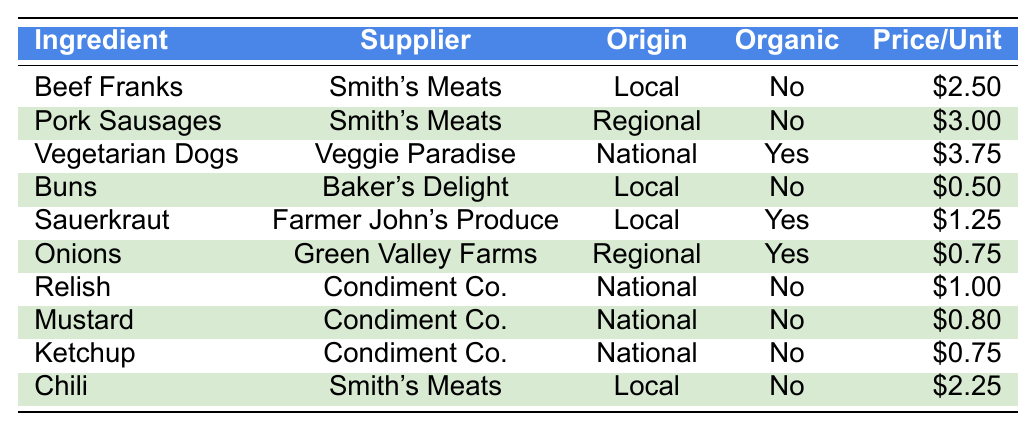What is the price per unit of vegetarian dogs? From the table, the entry for vegetarian dogs shows the price per unit is $3.75.
Answer: $3.75 Which supplier provides onions? According to the table, onions are supplied by Green Valley Farms.
Answer: Green Valley Farms How many ingredients are organic? In the table, there are 4 ingredients marked as organic: vegetarian dogs, sauerkraut, onions. The total count is therefore 3.
Answer: 3 Are all the buns supplied by Baker's Delight organic? The table indicates that the buns from Baker's Delight are not organic, making the statement false.
Answer: No What is the total price per unit for all ingredients supplied by Smith's Meats? Smith's Meats supplies beef franks ($2.50), pork sausages ($3.00), and chili ($2.25). The total price is $2.50 + $3.00 + $2.25 = $7.75.
Answer: $7.75 How much does the supplier of mustard charge compared to the supplier of sauerkraut? Mustard (Condiment Co.) costs $0.80, whereas sauerkraut (Farmer John's Produce) costs $1.25. Thus, sauerkraut is $1.25 - $0.80 = $0.45 more expensive.
Answer: $0.45 more expensive Which ingredient has the highest price per unit and what is it? The table shows vegetarian dogs priced at $3.75 as the highest cost per unit among the listed ingredients.
Answer: Vegetarian dogs, $3.75 Is it true that all the ingredients are locally sourced? The table reveals that not all ingredients are locally sourced; some are from national or regional suppliers, making the statement false.
Answer: No What is the average price per unit of the organic ingredients? The organic ingredients are vegetarian dogs ($3.75), sauerkraut ($1.25), and onions ($0.75). The total price is $3.75 + $1.25 + $0.75 = $5.75, and there are 3 ingredients. The average is $5.75 / 3 ≈ $1.92.
Answer: $1.92 Which ingredient holds the lowest price and what is that price? From the table, buns are shown to be the lowest at a price of $0.50 per unit.
Answer: $0.50 